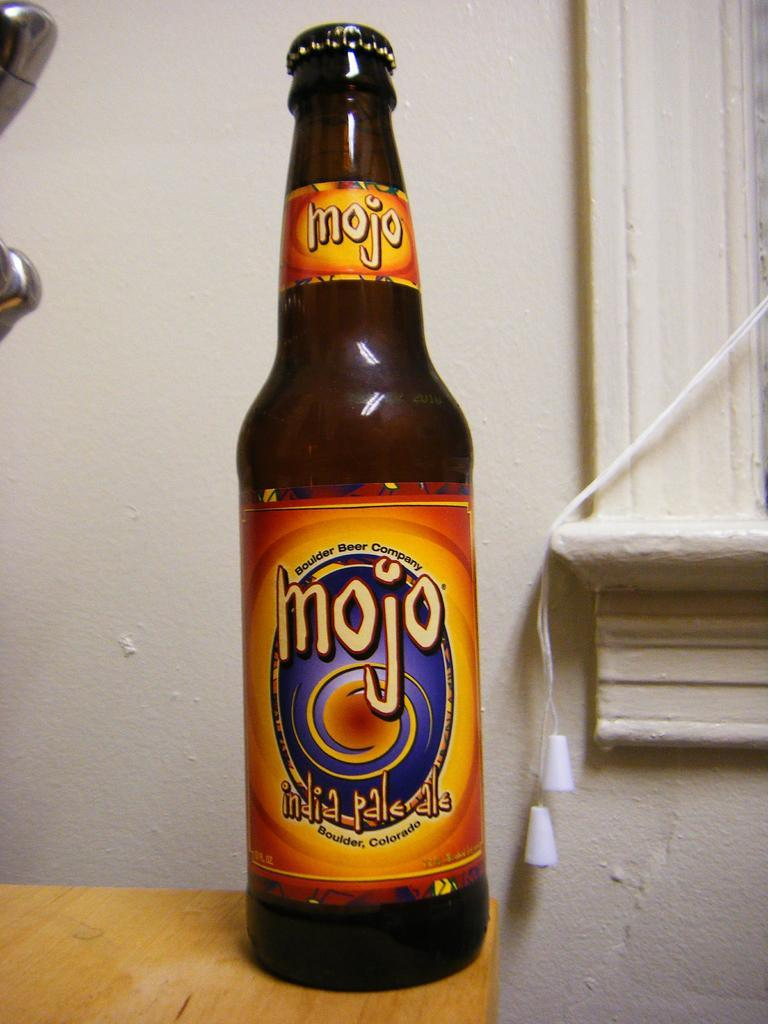<image>
Write a terse but informative summary of the picture. Mojo Pale Ale, Boulder Colorado is labeled on this beer bottle. 